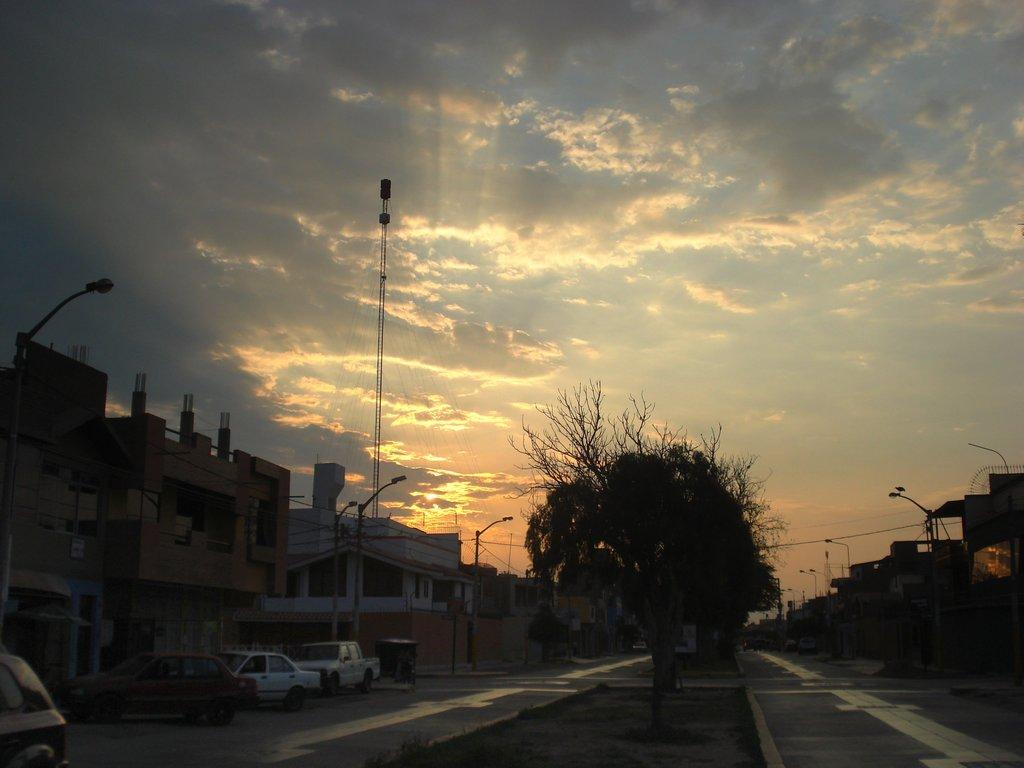What type of structures can be seen in the image? There are buildings in the image. What else can be seen near the buildings? There are vehicles on the road near the buildings. Are there any lighting fixtures in the image? Yes, there are street lights in the image. What other natural elements can be seen in the image? There are trees in the image. What is the object that looks like a rod in the image? There is a rod in the image. What can be seen in the background of the image? The sky with clouds is visible in the background of the image. Where is the drawer located in the image? There is no drawer present in the image. What type of record can be seen playing on the street in the image? There is no record or music playing in the image; it features buildings, vehicles, street lights, trees, a rod, and a sky with clouds. 